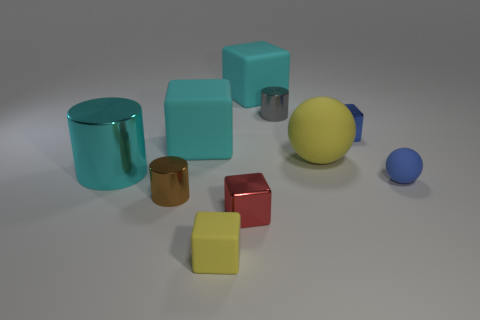Subtract all yellow cubes. How many cubes are left? 4 Subtract all balls. How many objects are left? 8 Add 2 large purple shiny things. How many large purple shiny things exist? 2 Subtract 1 yellow blocks. How many objects are left? 9 Subtract all large yellow rubber spheres. Subtract all red shiny things. How many objects are left? 8 Add 2 tiny gray metal objects. How many tiny gray metal objects are left? 3 